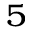<formula> <loc_0><loc_0><loc_500><loc_500>_ { 5 }</formula> 